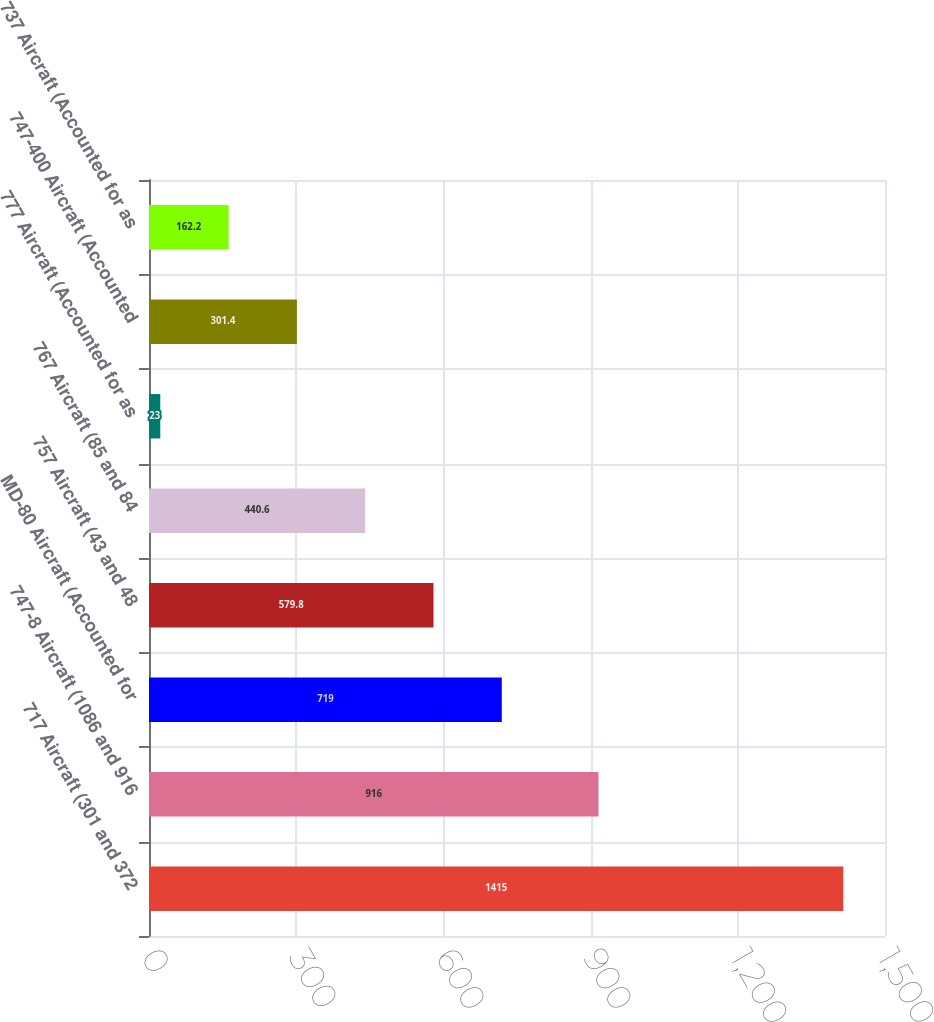<chart> <loc_0><loc_0><loc_500><loc_500><bar_chart><fcel>717 Aircraft (301 and 372<fcel>747-8 Aircraft (1086 and 916<fcel>MD-80 Aircraft (Accounted for<fcel>757 Aircraft (43 and 48<fcel>767 Aircraft (85 and 84<fcel>777 Aircraft (Accounted for as<fcel>747-400 Aircraft (Accounted<fcel>737 Aircraft (Accounted for as<nl><fcel>1415<fcel>916<fcel>719<fcel>579.8<fcel>440.6<fcel>23<fcel>301.4<fcel>162.2<nl></chart> 